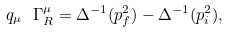Convert formula to latex. <formula><loc_0><loc_0><loc_500><loc_500>q _ { \mu } \ \Gamma ^ { \mu } _ { R } = \Delta ^ { - 1 } ( p ^ { 2 } _ { f } ) - \Delta ^ { - 1 } ( p ^ { 2 } _ { i } ) ,</formula> 